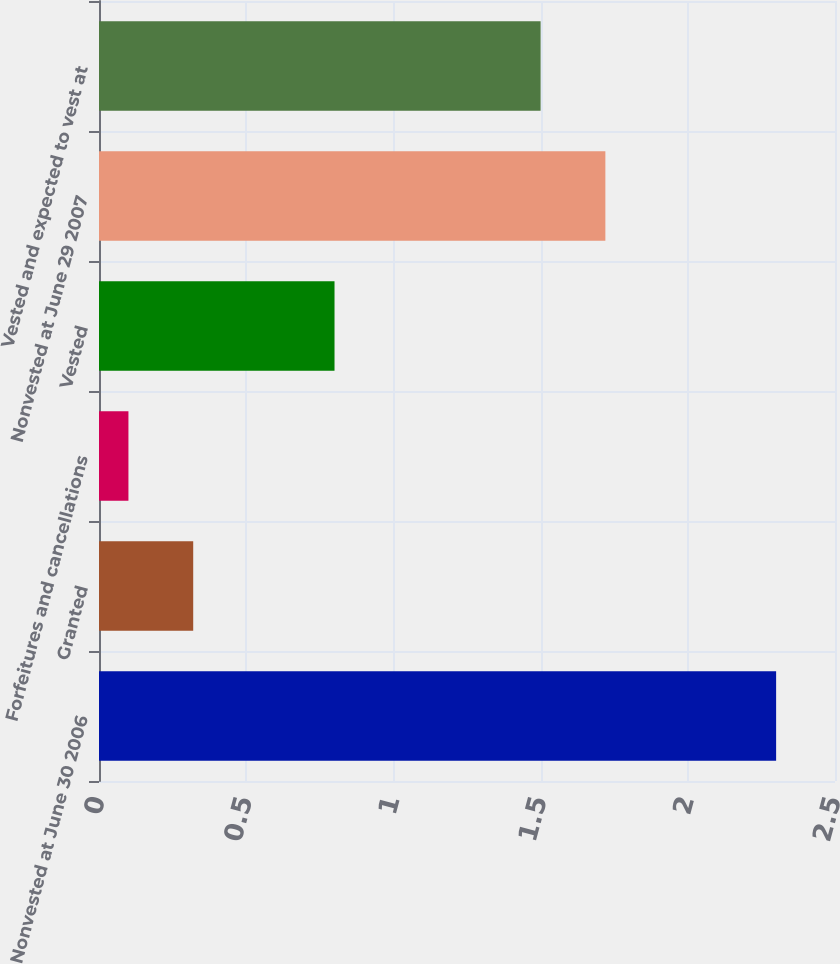Convert chart to OTSL. <chart><loc_0><loc_0><loc_500><loc_500><bar_chart><fcel>Nonvested at June 30 2006<fcel>Granted<fcel>Forfeitures and cancellations<fcel>Vested<fcel>Nonvested at June 29 2007<fcel>Vested and expected to vest at<nl><fcel>2.3<fcel>0.32<fcel>0.1<fcel>0.8<fcel>1.72<fcel>1.5<nl></chart> 